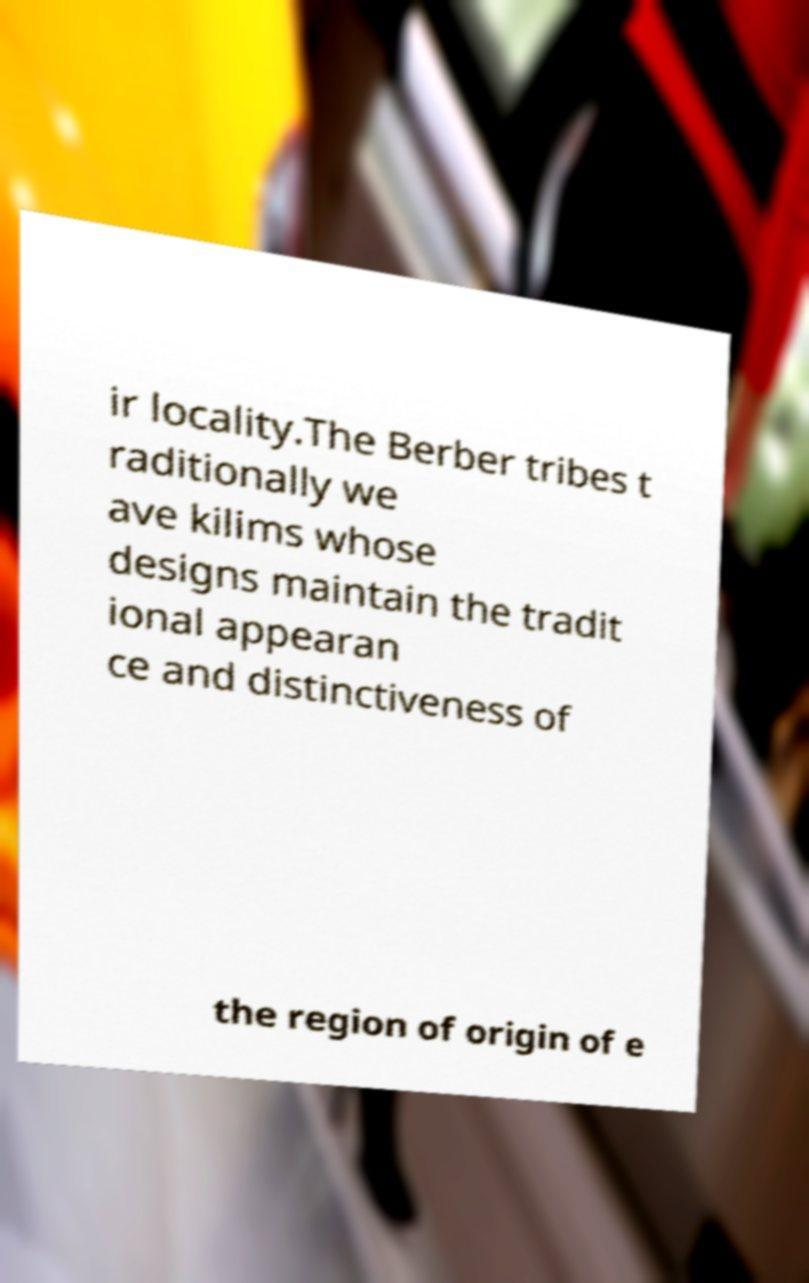Could you extract and type out the text from this image? ir locality.The Berber tribes t raditionally we ave kilims whose designs maintain the tradit ional appearan ce and distinctiveness of the region of origin of e 